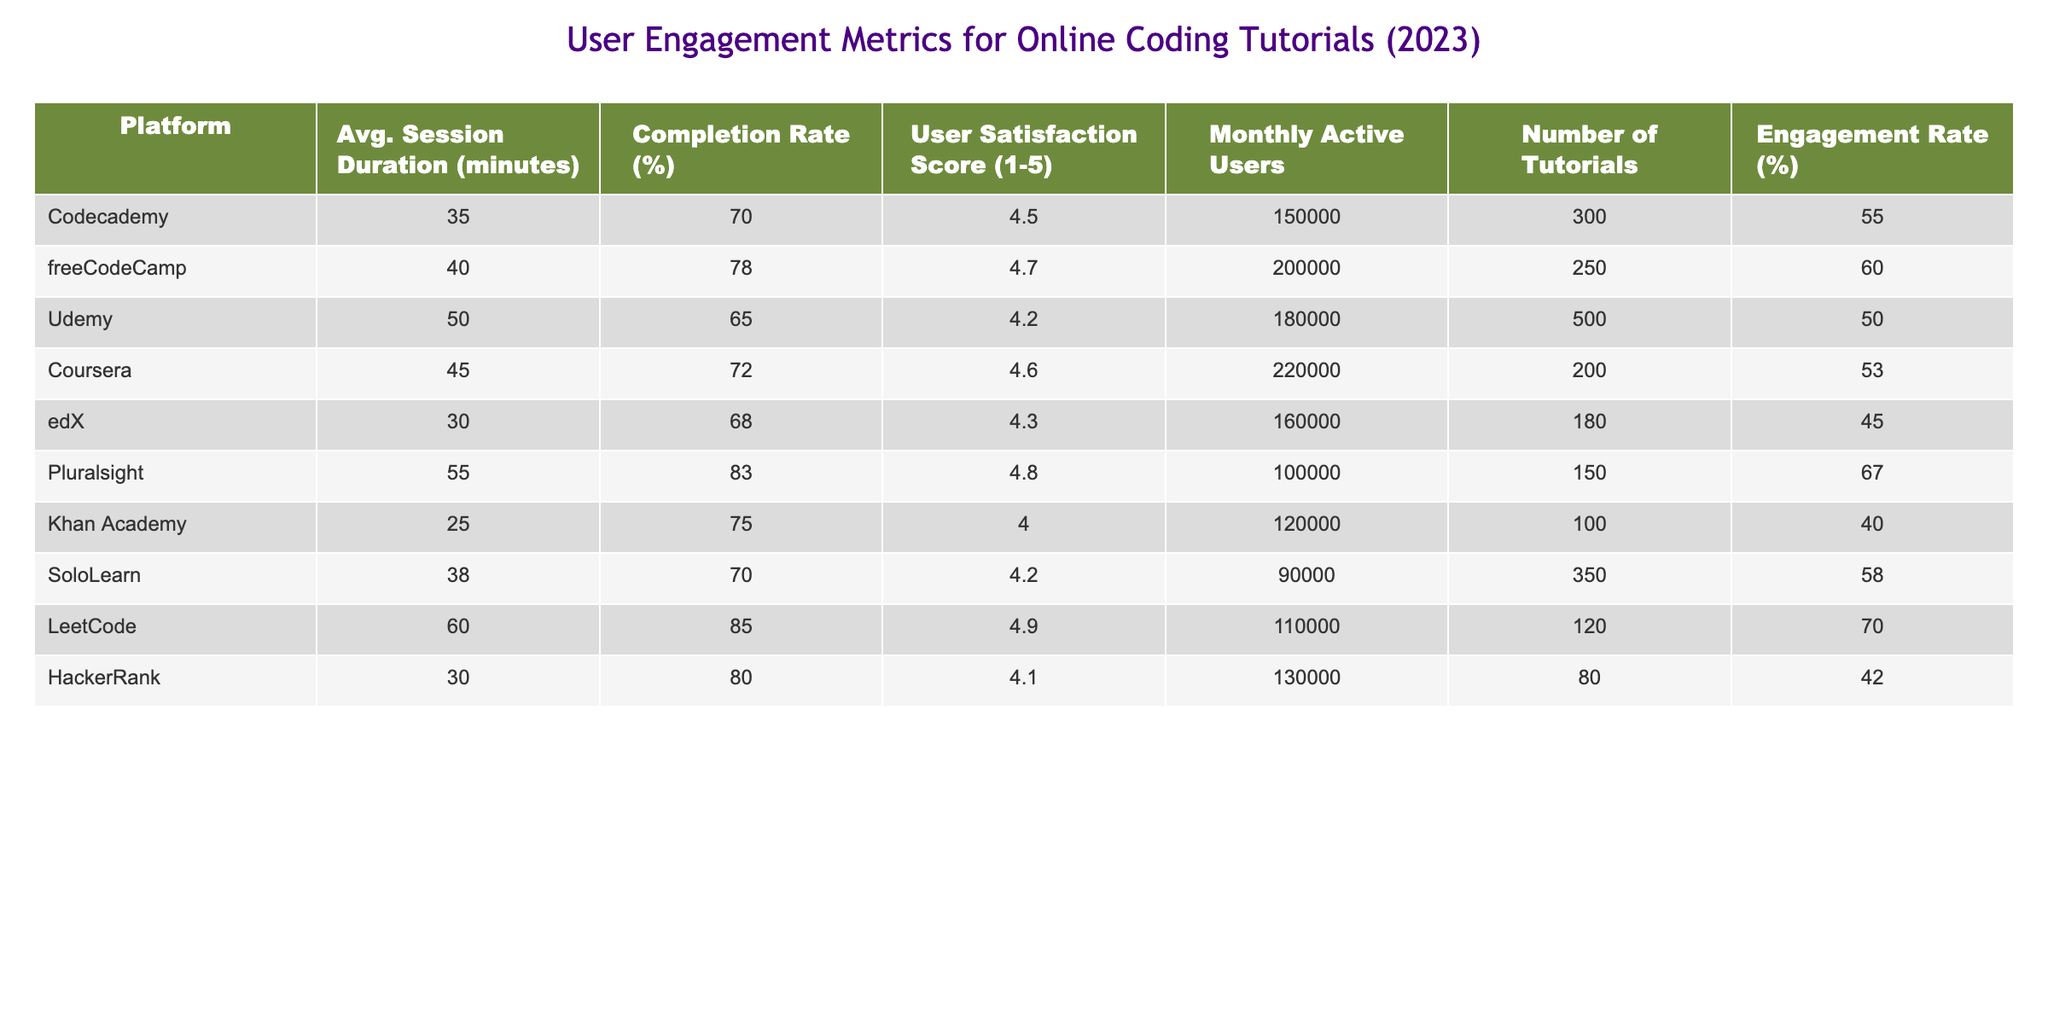What's the platform with the highest average session duration? The table shows that Pluralsight has the highest average session duration at 55 minutes.
Answer: Pluralsight Which platform has the lowest user satisfaction score? By inspecting the user satisfaction scores listed, Khan Academy has the lowest score of 4.0.
Answer: Khan Academy What is the completion rate of LeetCode? LeetCode's completion rate, as shown in the table, is 85%.
Answer: 85% Calculate the average number of monthly active users across all platforms. The total number of monthly active users is 1,510,000 (150,000 + 200,000 + 180,000 + 220,000 + 160,000 + 100,000 + 120,000 + 90,000 + 110,000 + 130,000 = 1,510,000). There are 10 platforms, so the average is 1,510,000 divided by 10, which equals 151,000.
Answer: 151000 Is there a platform with a completion rate above 80%? Yes, platforms with a completion rate above 80% are freeCodeCamp, Pluralsight, and LeetCode.
Answer: Yes Which platform has the highest engagement rate and what is it? The highest engagement rate is 70%, which belongs to LeetCode.
Answer: 70% How many tutorials does Udemy offer compared to SoloLearn? Udemy offers 500 tutorials while SoloLearn has 350 tutorials. The difference is 500 - 350 = 150.
Answer: 150 What is the total number of tutorials offered by all platforms? The total number of tutorials is calculated by summing the tutorials for each platform (300 + 250 + 500 + 200 + 180 + 150 + 100 + 350 + 120 + 80 = 2,230).
Answer: 2230 Does freeCodeCamp have a higher completion rate than Coursera? Yes, freeCodeCamp's completion rate is 78%, which is higher than Coursera's 72%.
Answer: Yes 